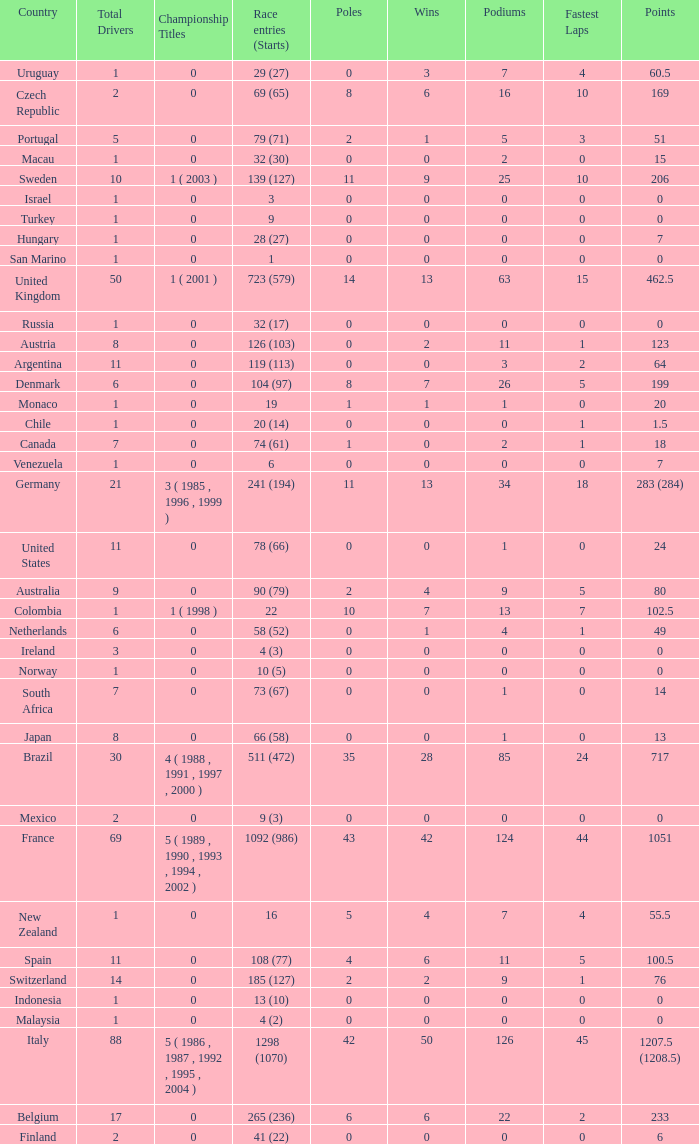How many fastest laps for the nation with 32 (30) entries and starts and fewer than 2 podiums? None. 